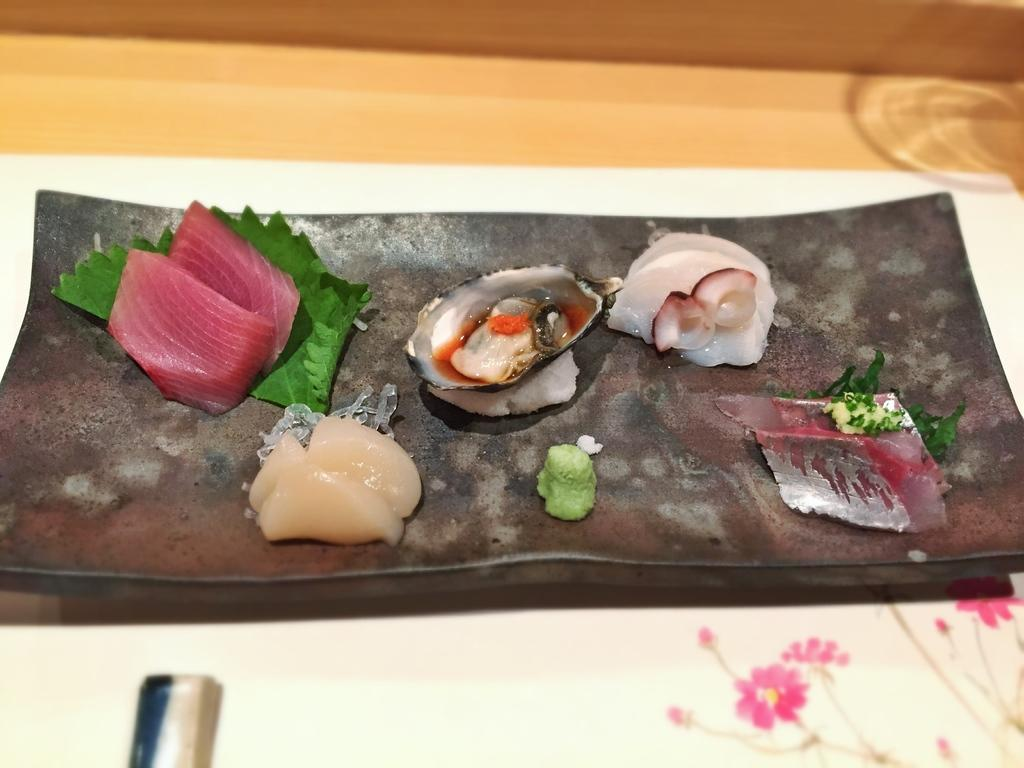What is on the tray that is visible in the image? There are food items on a tray in the image. What is the color of the surface on which the tray is placed? The tray is placed on a white surface. What type of material is the wooden piece made of? The wooden piece at the top of the image is made of wood. What is the profit margin of the food items on the tray in the image? There is no information about the profit margin of the food items in the image. 